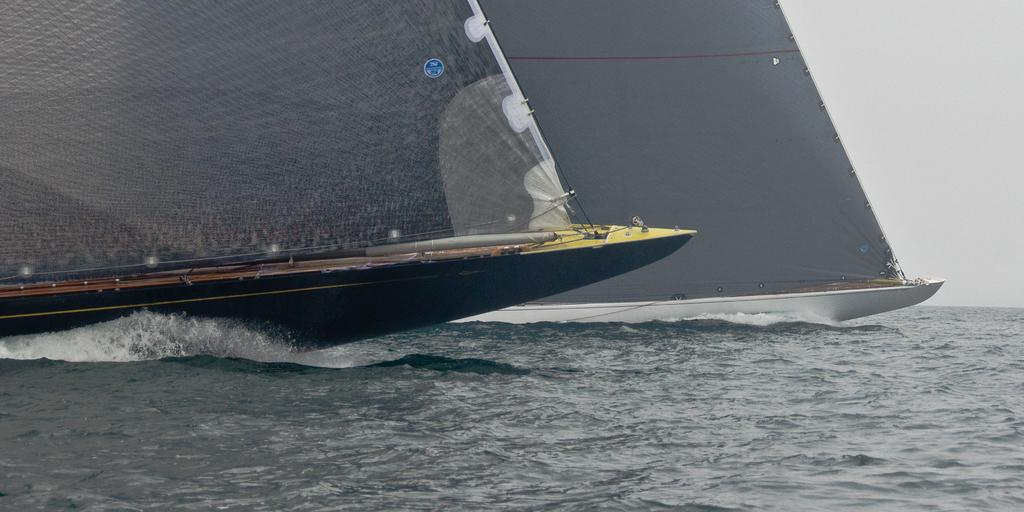What type of vehicles are in the image? There are boats in the image. Where are the boats located? The boats are on the water. What can be seen in the background of the image? There is sky visible in the background of the image. What type of operation is being performed on the boats in the image? There is no operation being performed on the boats in the image; they are simply floating on the water. 